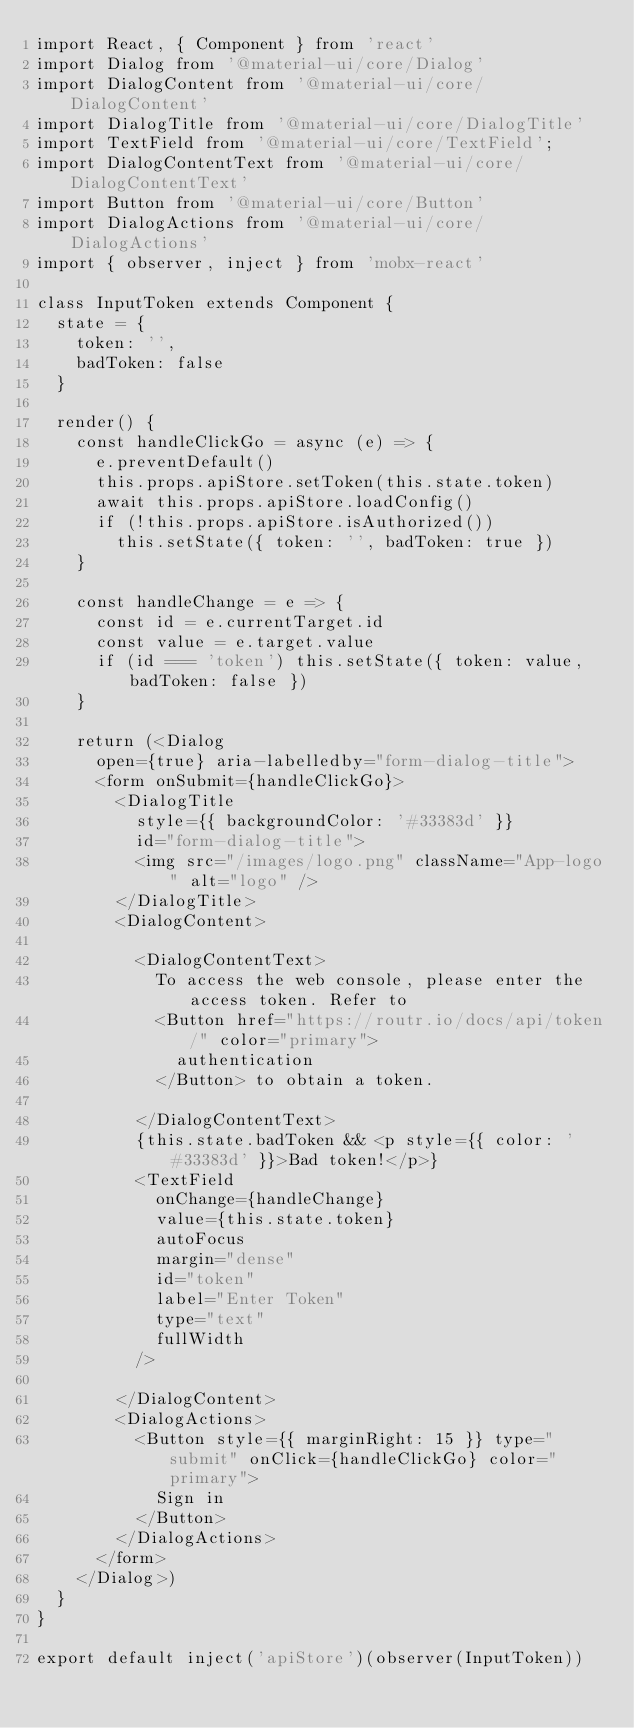<code> <loc_0><loc_0><loc_500><loc_500><_JavaScript_>import React, { Component } from 'react'
import Dialog from '@material-ui/core/Dialog'
import DialogContent from '@material-ui/core/DialogContent'
import DialogTitle from '@material-ui/core/DialogTitle'
import TextField from '@material-ui/core/TextField';
import DialogContentText from '@material-ui/core/DialogContentText'
import Button from '@material-ui/core/Button'
import DialogActions from '@material-ui/core/DialogActions'
import { observer, inject } from 'mobx-react'

class InputToken extends Component {
  state = {
    token: '',
    badToken: false
  }

  render() {
    const handleClickGo = async (e) => {
      e.preventDefault()
      this.props.apiStore.setToken(this.state.token)
      await this.props.apiStore.loadConfig()
      if (!this.props.apiStore.isAuthorized())
        this.setState({ token: '', badToken: true })
    }

    const handleChange = e => {
      const id = e.currentTarget.id
      const value = e.target.value
      if (id === 'token') this.setState({ token: value, badToken: false })
    }

    return (<Dialog
      open={true} aria-labelledby="form-dialog-title">
      <form onSubmit={handleClickGo}>
        <DialogTitle
          style={{ backgroundColor: '#33383d' }}
          id="form-dialog-title">
          <img src="/images/logo.png" className="App-logo" alt="logo" />
        </DialogTitle>
        <DialogContent>

          <DialogContentText>
            To access the web console, please enter the access token. Refer to
            <Button href="https://routr.io/docs/api/token/" color="primary">
              authentication
            </Button> to obtain a token.

          </DialogContentText>
          {this.state.badToken && <p style={{ color: '#33383d' }}>Bad token!</p>}
          <TextField
            onChange={handleChange}
            value={this.state.token}
            autoFocus
            margin="dense"
            id="token"
            label="Enter Token"
            type="text"
            fullWidth
          />

        </DialogContent>
        <DialogActions>
          <Button style={{ marginRight: 15 }} type="submit" onClick={handleClickGo} color="primary">
            Sign in
          </Button>
        </DialogActions>
      </form>
    </Dialog>)
  }
}

export default inject('apiStore')(observer(InputToken))
</code> 